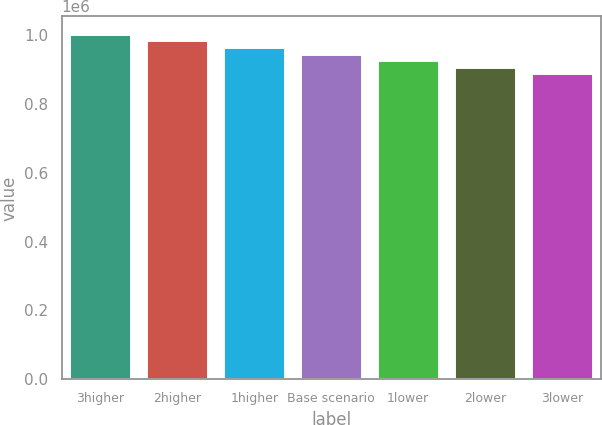<chart> <loc_0><loc_0><loc_500><loc_500><bar_chart><fcel>3higher<fcel>2higher<fcel>1higher<fcel>Base scenario<fcel>1lower<fcel>2lower<fcel>3lower<nl><fcel>1.00469e+06<fcel>985278<fcel>966053<fcel>947018<fcel>927983<fcel>908758<fcel>889345<nl></chart> 